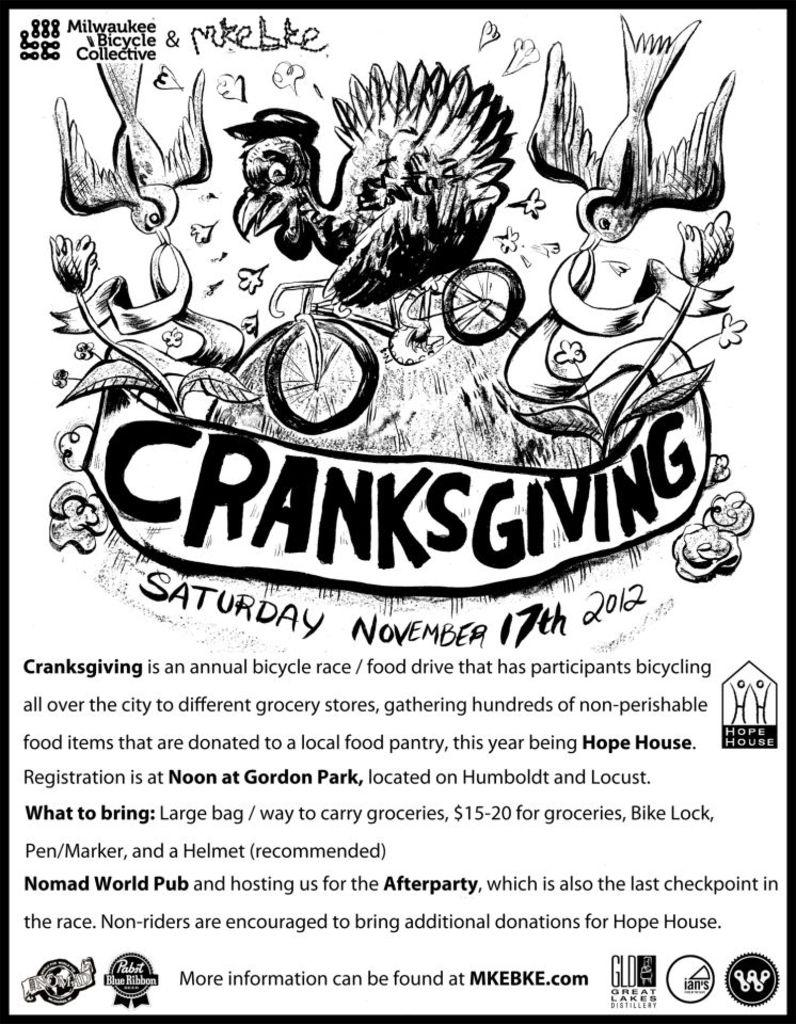<image>
Offer a succinct explanation of the picture presented. A sign describes an annual bike race and food drive called Cranksgiving. 